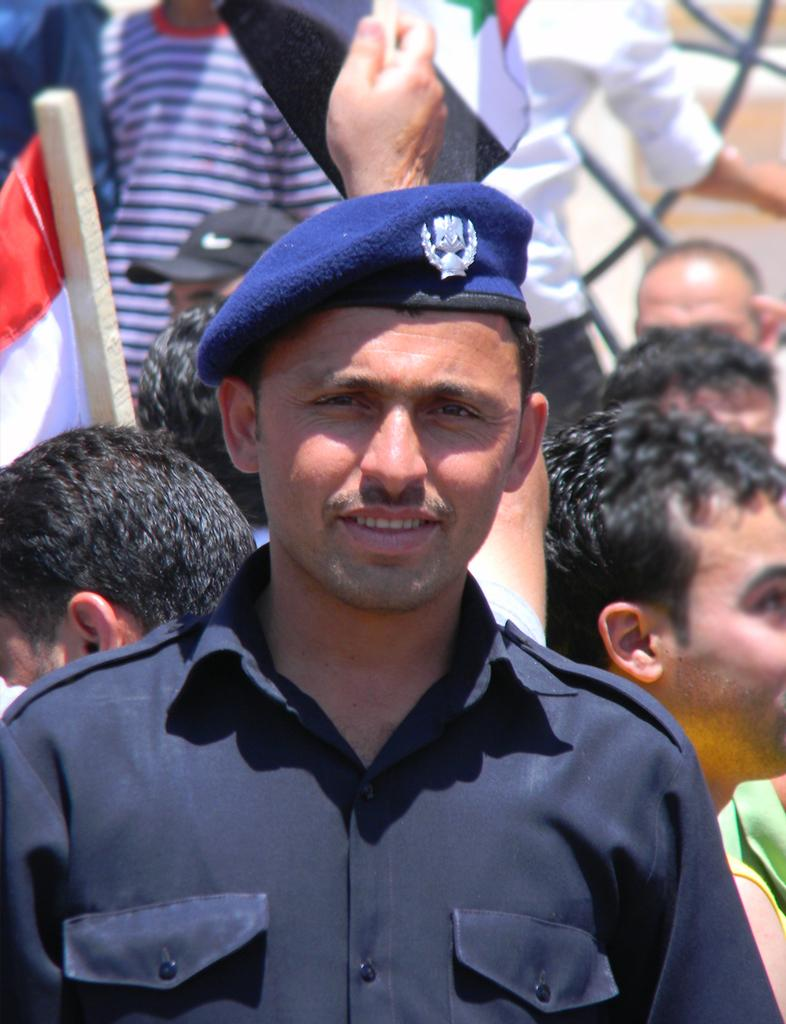What is the man in the image wearing? The man is wearing a uniform in the image. What type of headgear is the man wearing? The man is wearing a blue cap. Can you describe the people in the background of the image? There are other persons in the background of the image. What is attached to a wooden stick in the image? There is a flag attached to a wooden stick in the image. What type of oatmeal is being served in the image? There is no oatmeal present in the image. What idea does the flag in the image represent? The image does not provide any information about the meaning or idea represented by the flag. 